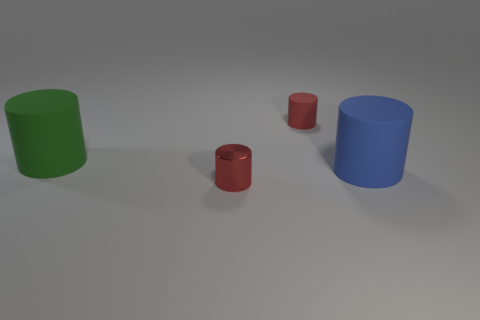Add 3 large purple rubber objects. How many objects exist? 7 Subtract 2 red cylinders. How many objects are left? 2 Subtract all red metal objects. Subtract all big blue cylinders. How many objects are left? 2 Add 2 large green things. How many large green things are left? 3 Add 4 tiny objects. How many tiny objects exist? 6 